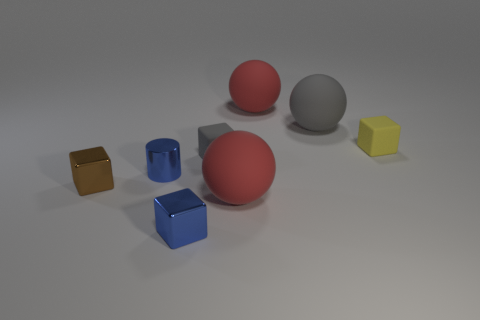Which object stands out the most based on its color? The yellow cube stands out the most due to its bright and contrasting color compared to the rest of the objects and the neutral background. 